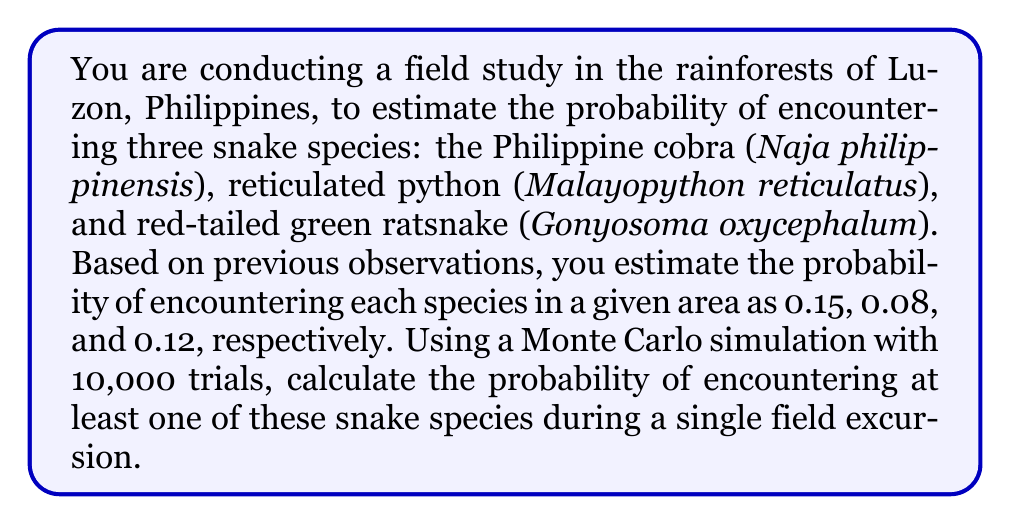Help me with this question. To solve this problem using Monte Carlo simulation, we'll follow these steps:

1. Set up the simulation:
   - Number of trials: $n = 10,000$
   - Probabilities: $p_{cobra} = 0.15$, $p_{python} = 0.08$, $p_{ratsnake} = 0.12$

2. For each trial, simulate the encounter of each snake species:
   - Generate a random number $r_i \in [0,1]$ for each species
   - If $r_i \leq p_i$, consider it an encounter

3. Count the number of trials where at least one snake is encountered:
   - If any of the three species is encountered, increment the counter

4. Calculate the probability:
   $P(\text{at least one snake}) = \frac{\text{number of successful trials}}{\text{total number of trials}}$

Python code for the simulation:

```python
import random

n_trials = 10000
p_cobra, p_python, p_ratsnake = 0.15, 0.08, 0.12
count = 0

for _ in range(n_trials):
    cobra = random.random() <= p_cobra
    python = random.random() <= p_python
    ratsnake = random.random() <= p_ratsnake
    
    if cobra or python or ratsnake:
        count += 1

probability = count / n_trials
```

5. Theoretical probability calculation:
   We can verify our simulation result using the complement of the probability of encountering no snakes:

   $P(\text{at least one snake}) = 1 - P(\text{no snakes})$
   $= 1 - (1-p_{cobra})(1-p_{python})(1-p_{ratsnake})$
   $= 1 - (0.85)(0.92)(0.88)$
   $= 1 - 0.6877$
   $= 0.3123$

The Monte Carlo simulation should yield a result close to this theoretical probability.
Answer: $\approx 0.3123$ or $31.23\%$ 